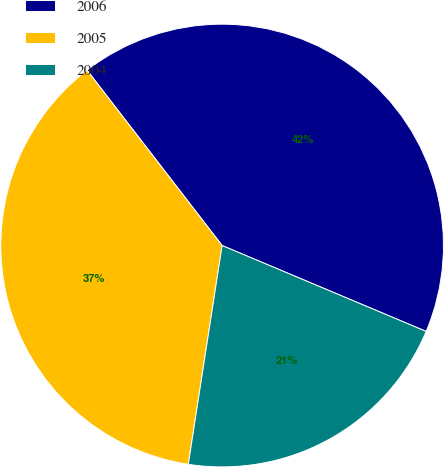Convert chart. <chart><loc_0><loc_0><loc_500><loc_500><pie_chart><fcel>2006<fcel>2005<fcel>2004<nl><fcel>41.79%<fcel>37.11%<fcel>21.1%<nl></chart> 